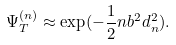<formula> <loc_0><loc_0><loc_500><loc_500>\Psi ^ { ( n ) } _ { T } \approx \exp ( - \frac { 1 } { 2 } n b ^ { 2 } d ^ { 2 } _ { n } ) .</formula> 